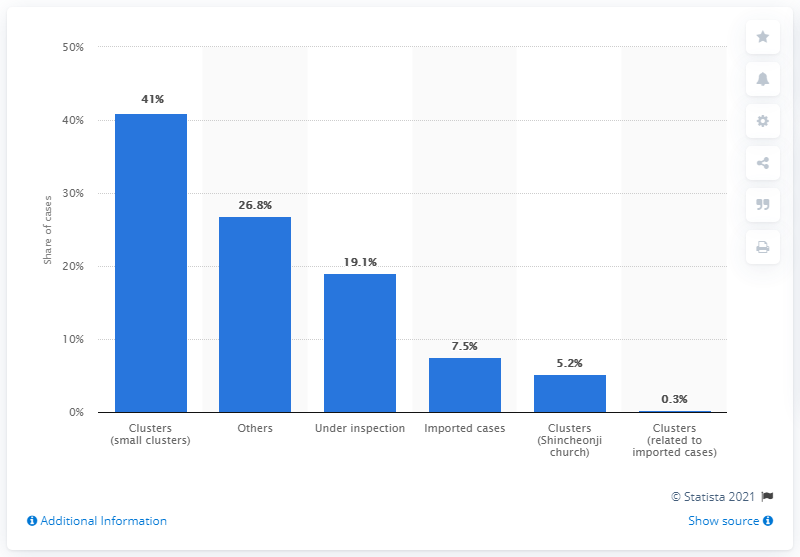Highlight a few significant elements in this photo. There are currently 41 daily confirmed cases of COVID-19 in Korea. A total of 41% of the COVID-19 confirmed cases in South Korea were attributed to small clusters of infections. 